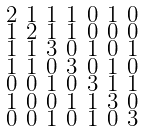<formula> <loc_0><loc_0><loc_500><loc_500>\begin{smallmatrix} 2 & 1 & 1 & 1 & 0 & 1 & 0 \\ 1 & 2 & 1 & 1 & 0 & 0 & 0 \\ 1 & 1 & 3 & 0 & 1 & 0 & 1 \\ 1 & 1 & 0 & 3 & 0 & 1 & 0 \\ 0 & 0 & 1 & 0 & 3 & 1 & 1 \\ 1 & 0 & 0 & 1 & 1 & 3 & 0 \\ 0 & 0 & 1 & 0 & 1 & 0 & 3 \end{smallmatrix}</formula> 